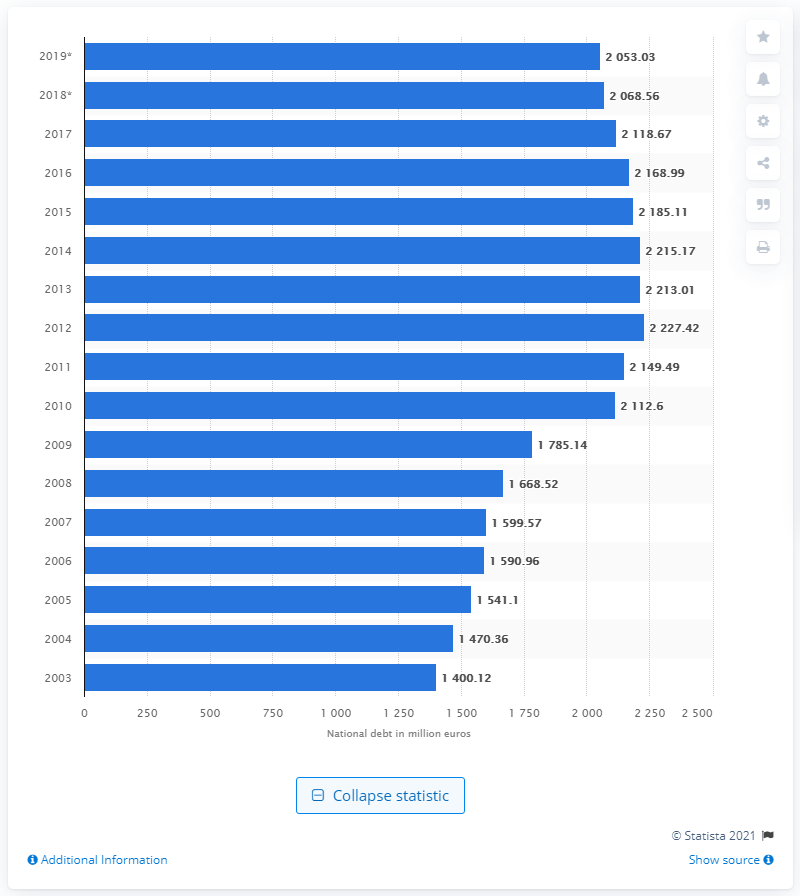Indicate a few pertinent items in this graphic. In 2019, Germany's general government debt was approximately 2,053.03. 